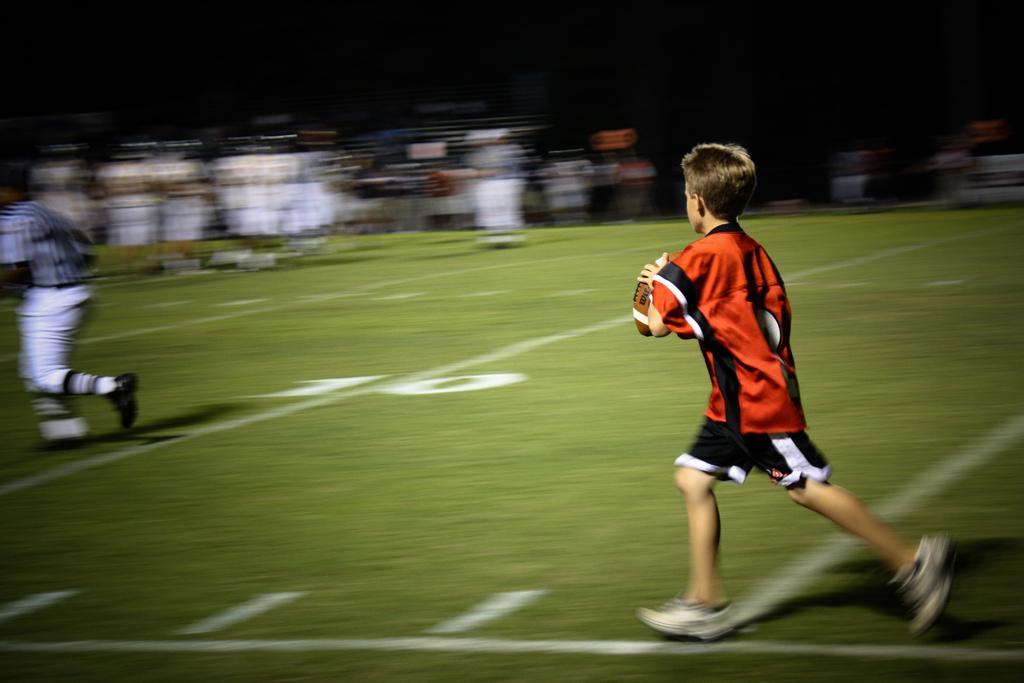Can you describe this image briefly? There are two persons running on the ground,one boy is holding a ball and in the background we can see it is blurry. 